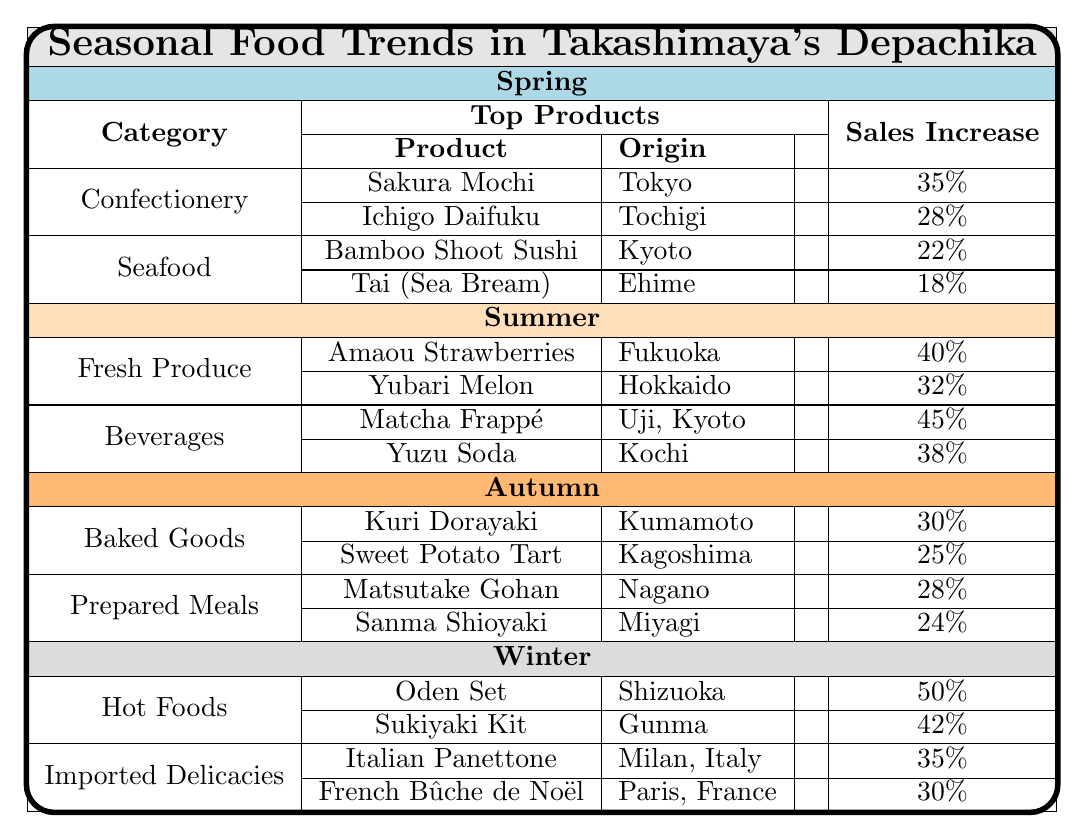What are the top two products in the Spring season under the Confectionery category? In the table under Spring and Confectionery, the top two products listed are Sakura Mochi and Ichigo Daifuku.
Answer: Sakura Mochi and Ichigo Daifuku Which season has the highest sales increase for Fresh Produce? In the Summer season, the top products in Fresh Produce are Amaou Strawberries with a sales increase of 40% and Yubari Melon with a sales increase of 32%. Thus, Summer has the highest sales increase for this category.
Answer: Summer Is there a product from the Autumn season with a sales increase greater than 26%? In Autumn, Matsutake Gohan has a sales increase of 28%, which is greater than 26%, confirming that there is at least one product with a higher sales increase.
Answer: Yes What is the total sales increase for Baked Goods in Autumn? The sales increases for the two Baked Goods are 30% for Kuri Dorayaki and 25% for Sweet Potato Tart. Adding these values gives 30% + 25% = 55%.
Answer: 55% Which category in Winter has a product with the highest sales increase? In the Winter section, the Hot Foods category includes the Oden Set with a 50% sales increase, which is higher than any product from the Imported Delicacies category, reaching 35%.
Answer: Hot Foods Are there any products from the Summer season that originate from Hokkaido? Yes, in the Summer season, the Yubari Melon originates from Hokkaido. Therefore, there is at least one product that fits the criteria.
Answer: Yes What is the average sales increase of the top products in the Seafood category for Spring? The sales increases for the Spring Seafood category are 22% for Bamboo Shoot Sushi and 18% for Tai (Sea Bream). The average is (22% + 18%) / 2 = 20%.
Answer: 20% Which season's top product has the highest sales increase overall? From the data, the Oden Set in Winter has the highest sales increase of 50%, which surpasses all other seasonal top products.
Answer: Winter What percentage increase does the Italian Panettone have compared to the Sukiyaki Kit? The Italian Panettone has a sales increase of 35%, while Sukiyaki Kit has 42%. The difference is 42% - 35% = 7%.
Answer: 7% How many products in total were listed under the Prepared Meals category for Autumn? The Prepared Meals category in Autumn lists two products: Matsutake Gohan and Sanma Shioyaki. Hence, the total number of products is 2.
Answer: 2 